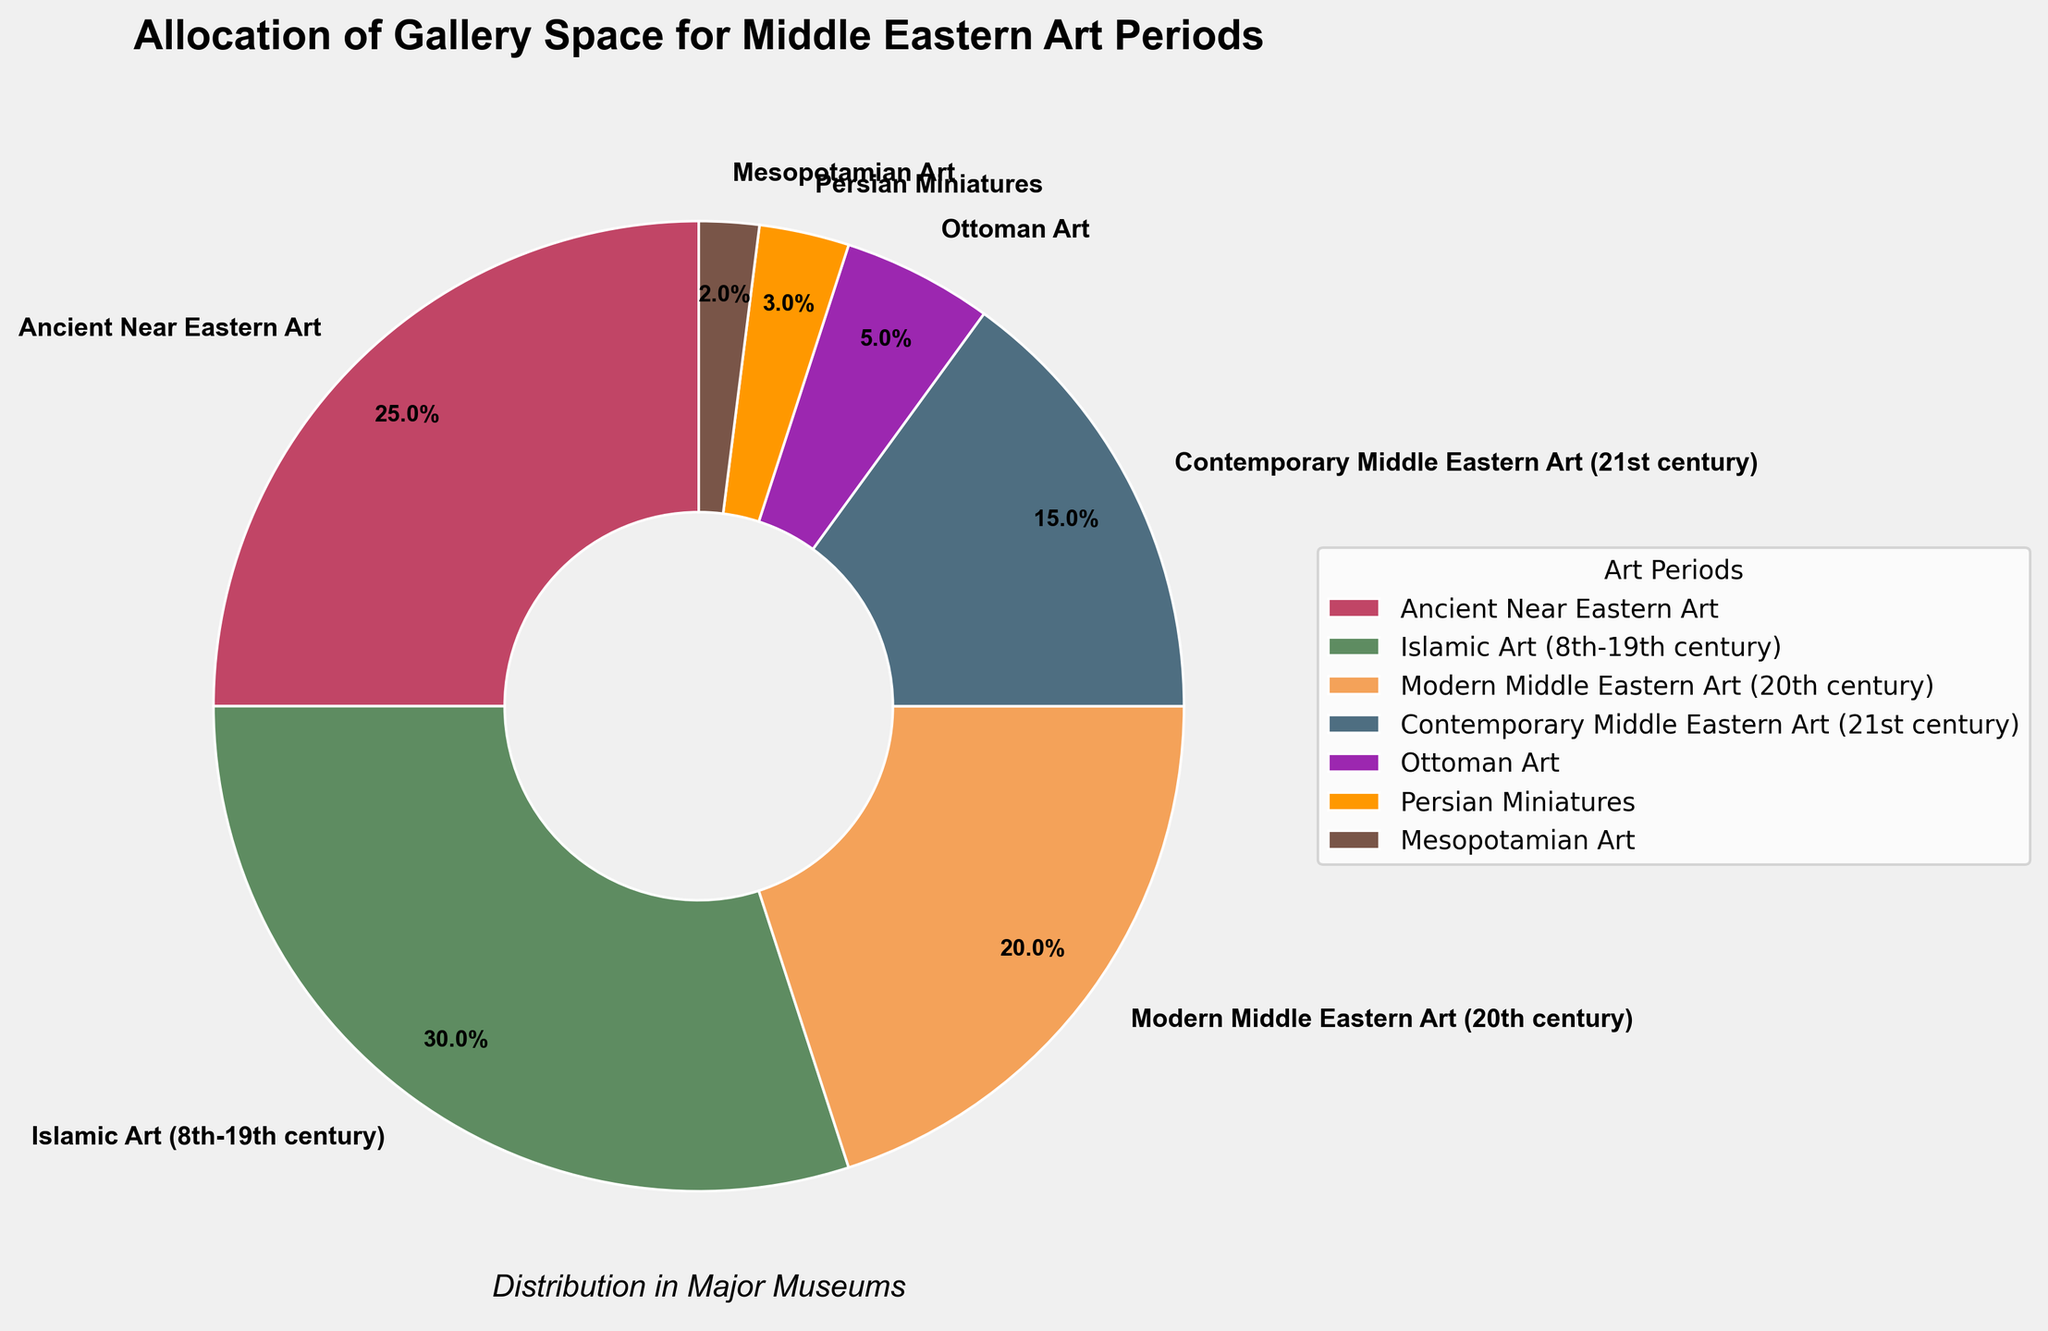What percentage of gallery space is allocated to Contemporary Middle Eastern Art? Observing the pie chart, Contemporary Middle Eastern Art is labeled with its share clearly marked as part of the chart.
Answer: 15% How does the allocation for Ancient Near Eastern Art compare to that of Islamic Art (8th-19th century)? The pie chart shows that Ancient Near Eastern Art is represented by 25%, while Islamic Art (8th-19th century) accounts for 30%. So, Islamic Art (8th-19th century) has a larger allocation.
Answer: Islamic Art (8th-19th century) has a larger allocation by 5% What is the combined percentage for both Modern and Contemporary Middle Eastern Art? By summing the percentages for Modern Middle Eastern Art (20th century) and Contemporary Middle Eastern Art (21st century), we get 20% + 15%.
Answer: 35% Which art period has the smallest allocation of gallery space, and what is its percentage? From the pie chart, Mesopotamian Art is the period with the smallest slice, labeled with its percentage.
Answer: Mesopotamian Art, 2% If the total gallery space is 1000 square meters, how much space is allocated to Modern Middle Eastern Art? Multiply the percentage allocation (20%) by the total gallery space (1000 square meters) to find the allocated space: 1000 * 0.20
Answer: 200 square meters Compare the combined allocation for Ancient Near Eastern Art and Persian Miniatures with the allocation for Islamic Art (8th-19th century). Which is greater? Summing the percentages for Ancient Near Eastern Art (25%) and Persian Miniatures (3%), we get 28%. Comparing this to Islamic Art (8th-19th century) which is 30%, the latter is greater.
Answer: Islamic Art (8th-19th century) is greater by 2% What can you infer about the allocation trends for ancient versus more modern Middle Eastern art periods based on the pie chart? Comparing the allocations, ancient (e.g., Ancient Near Eastern Art: 25%, Mesopotamian Art: 2%) tends towards lower combined percentages (27%) compared to more modern (e.g., Modern Middle Eastern Art: 20%, Contemporary Middle Eastern Art: 15%) which stands at 35%. This indicates a greater emphasis on more modern artworks.
Answer: Modern periods receive more space Which displayed color is associated with Ottoman Art on the pie chart? From a visual inspection, Ottoman Art is depicted with a distinct color among the pie slices.
Answer: Purple What is the difference in gallery space allocation between Ottoman Art and Persian Miniatures? Subtract the percentage of Persian Miniatures (3%) from the percentage of Ottoman Art (5%) to get the difference.
Answer: 2% What percentage of gallery space is allocated to art periods before the 20th century? Summing the percentages of Ancient Near Eastern Art (25%), Islamic Art (8th-19th century) (30%), Ottoman Art (5%), Persian Miniatures (3%), and Mesopotamian Art (2%) achieves the total pre-20th century allocation.
Answer: 65% 